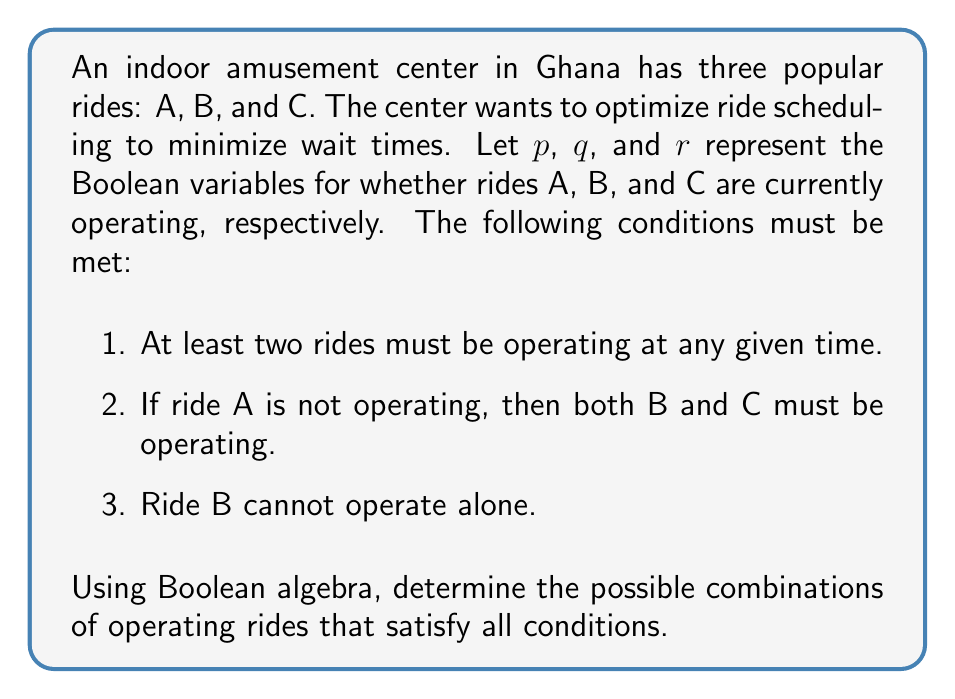Show me your answer to this math problem. Let's approach this step-by-step using Boolean logic:

1) First, let's express the given conditions as Boolean expressions:

   Condition 1: $pq + qr + pr \geq 1$
   Condition 2: $\overline{p} \rightarrow (q \wedge r)$, which is equivalent to $p \vee (q \wedge r)$
   Condition 3: $\overline{q} \vee (p \vee r)$

2) Now, we need to combine these conditions using the AND operator:

   $F(p,q,r) = (pq + qr + pr) \wedge (p \vee (q \wedge r)) \wedge (\overline{q} \vee (p \vee r))$

3) We can simplify this expression:

   $F(p,q,r) = (pq + qr + pr) \wedge (p \vee (q \wedge r)) \wedge (p \vee r \vee \overline{q})$

4) Now, let's consider all possible combinations of $p$, $q$, and $r$:

   000: Fails condition 1
   001: Fails condition 1
   010: Fails conditions 1 and 3
   011: Satisfies all conditions
   100: Fails condition 1
   101: Satisfies all conditions
   110: Satisfies all conditions
   111: Satisfies all conditions

5) Therefore, the valid combinations are:

   011: Only B and C are operating
   101: Only A and C are operating
   110: Only A and B are operating
   111: All rides are operating
Answer: $(0,1,1)$, $(1,0,1)$, $(1,1,0)$, $(1,1,1)$ 